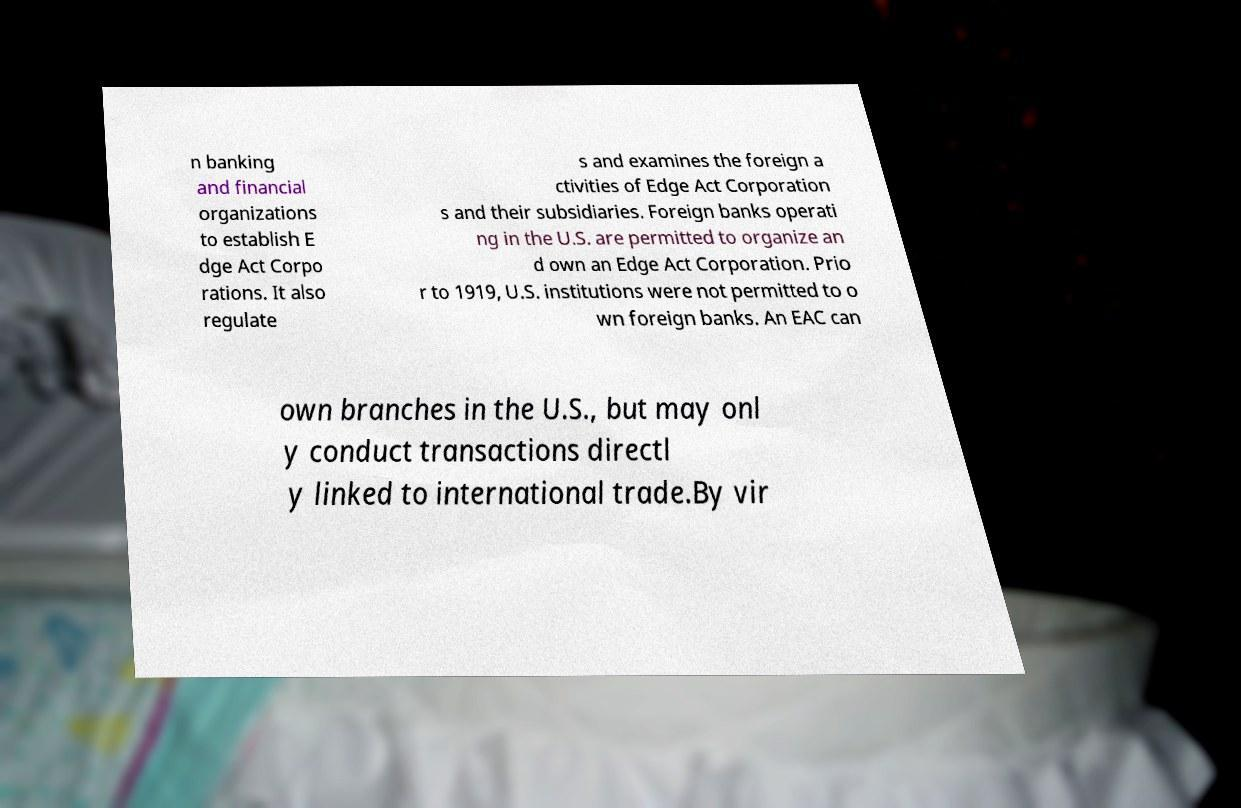There's text embedded in this image that I need extracted. Can you transcribe it verbatim? n banking and financial organizations to establish E dge Act Corpo rations. It also regulate s and examines the foreign a ctivities of Edge Act Corporation s and their subsidiaries. Foreign banks operati ng in the U.S. are permitted to organize an d own an Edge Act Corporation. Prio r to 1919, U.S. institutions were not permitted to o wn foreign banks. An EAC can own branches in the U.S., but may onl y conduct transactions directl y linked to international trade.By vir 